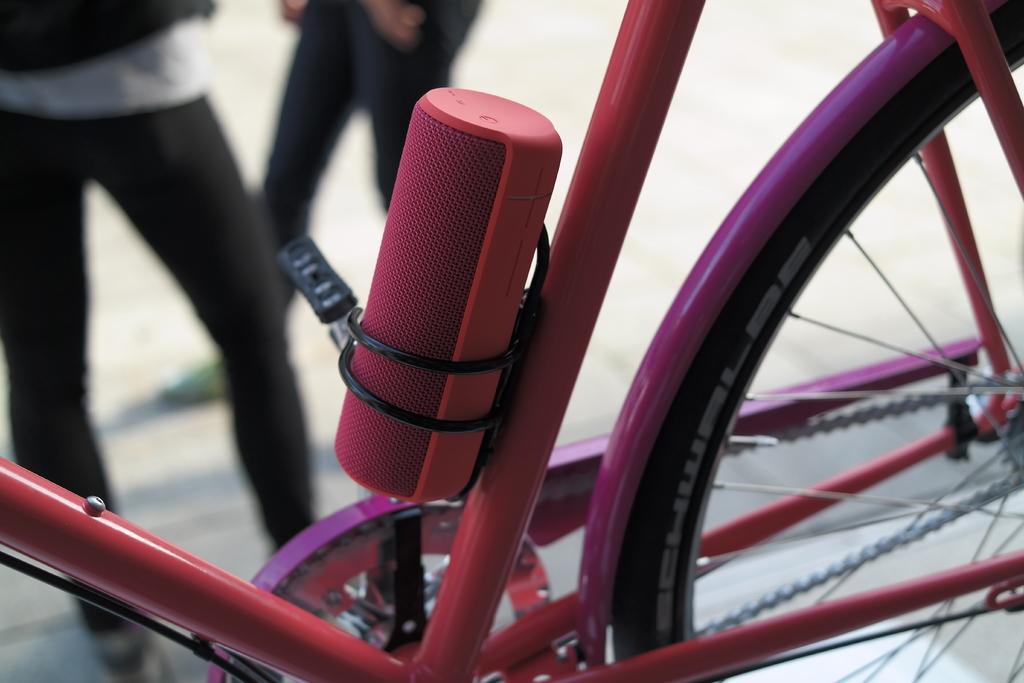What is the main object in the picture? There is a bicycle in the picture. Are there any people in the picture? Yes, there are people present beside the bicycle. How many ants can be seen carrying a twig on the bicycle in the image? There are no ants or twigs present on the bicycle in the image. 